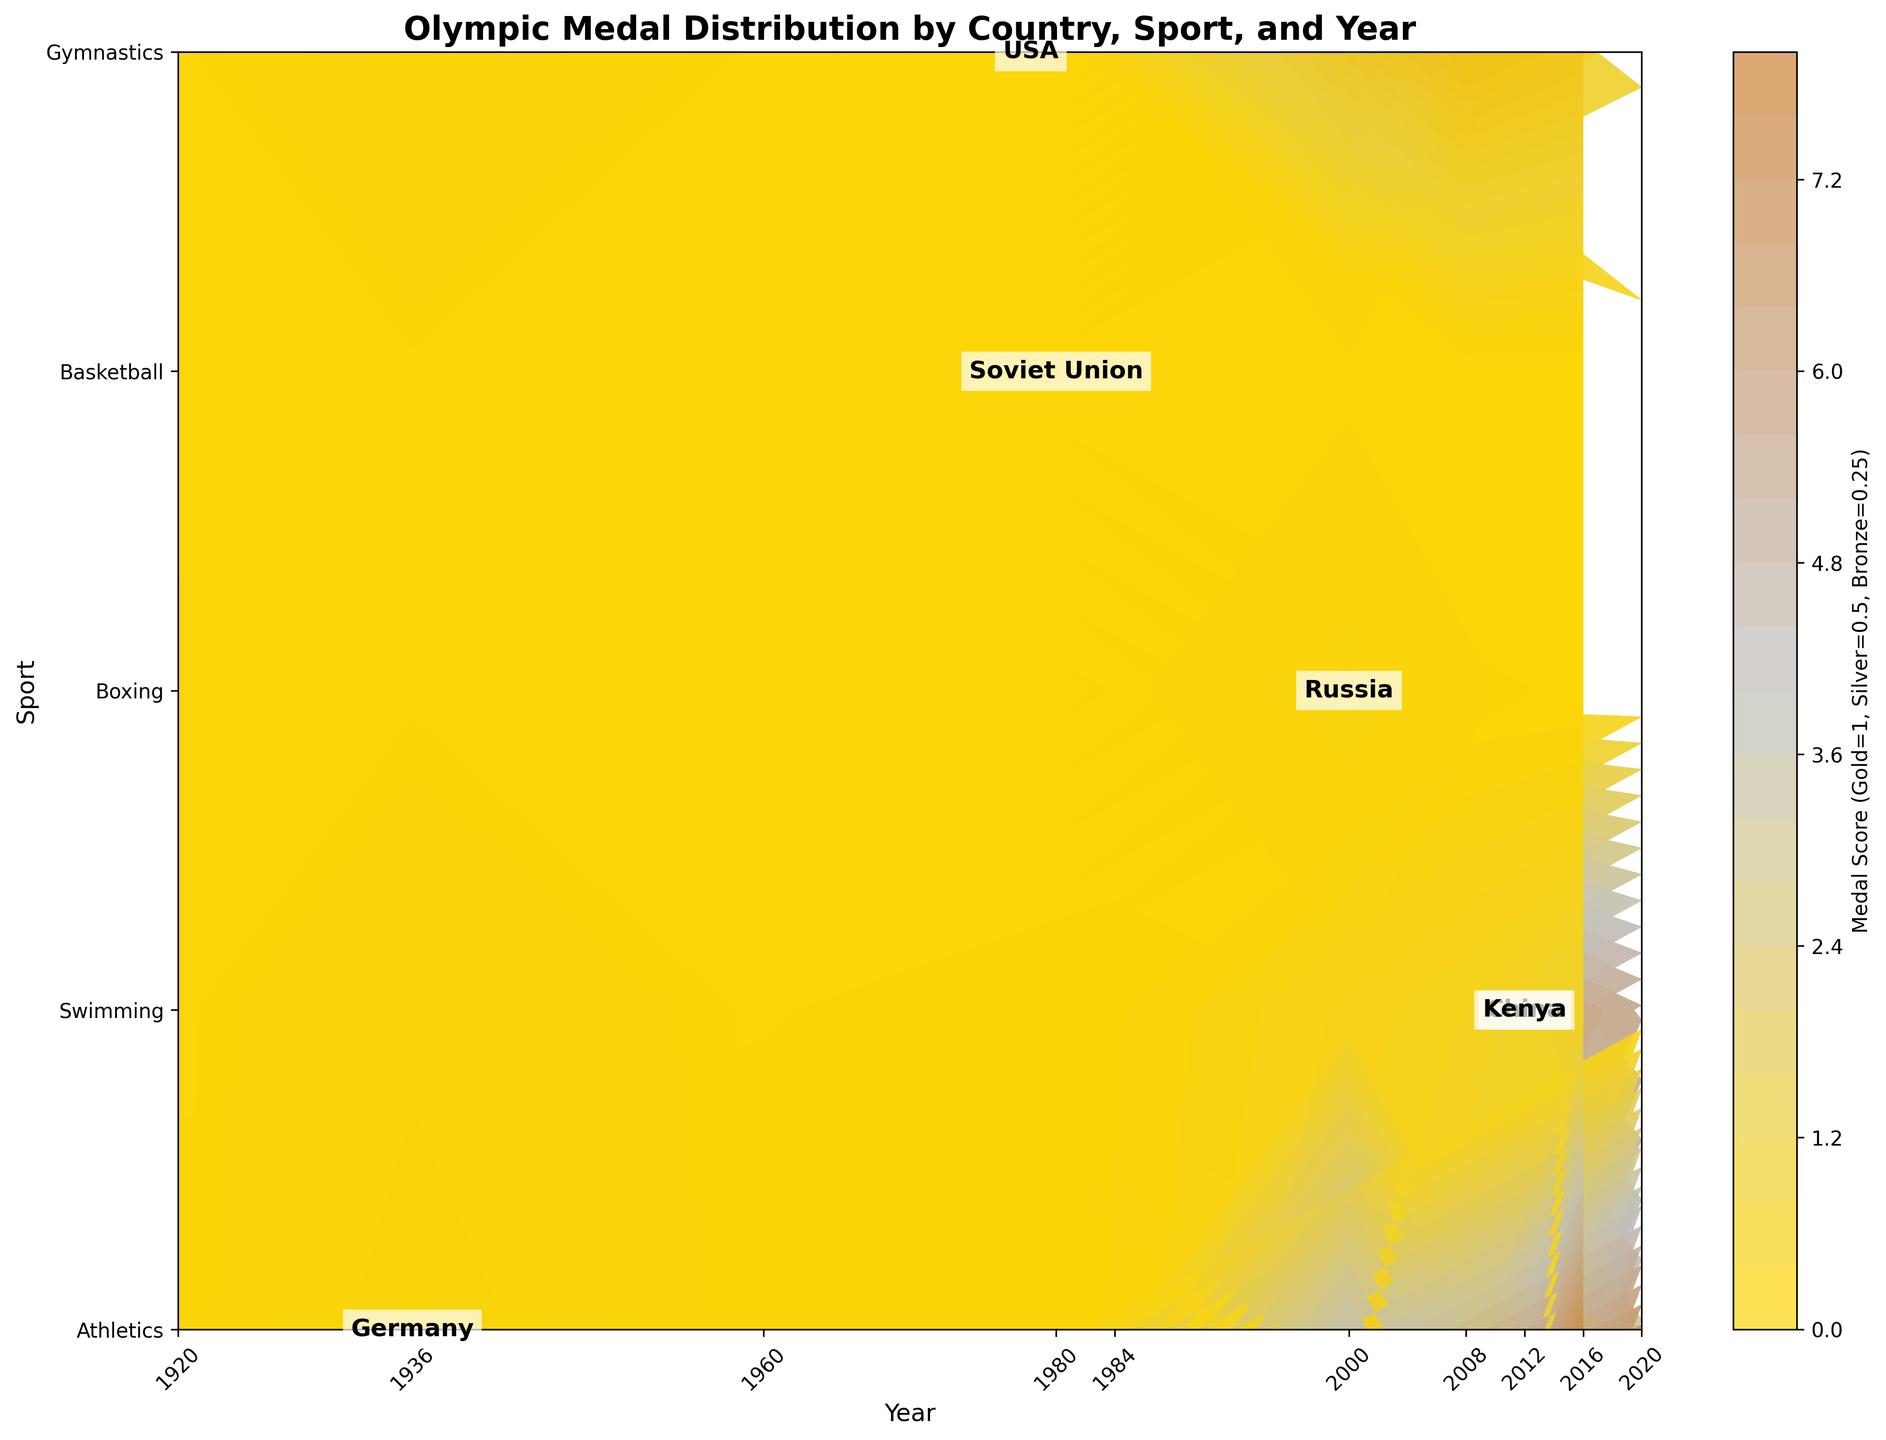What is the title of the figure? The title is usually located at the top of the figure and provides a summary of what the graph represents.
Answer: Olympic Medal Distribution by Country, Sport, and Year On which axis are the sports labeled? Typically, either the x-axis or y-axis is used to label different categories. In this case, the sports are labeled on the vertical axis.
Answer: y-axis Which sport does the USA win the most medals in the year 1984? To find this, locate the year 1984 on the x-axis, then look upwards to find the sport with the highest contour level for the USA.
Answer: Athletics How many countries are labeled in the figure? Count the number of unique country labels presented on the graph. The country labels are added as text on the plot.
Answer: 6 Does any country have a higher medal score in Swimming than USA in 2000? Compare the contour level for Swimming in the year 2000 among all countries. The USA's contour level for Swimming in 2000 must be compared to those of other countries for the same sport and year.
Answer: No Which country has the highest overall medal score in Gymnastics in 2012? Locate the year 2012 on the x-axis and find the contour levels corresponding to Gymnastics for all countries. The country with the highest contour level wins.
Answer: USA Which two sports show the highest medal scores for China in any year? Find the contour levels for China across all sports and all years, identifying the two sports with the highest contour levels.
Answer: Gymnastics and Athletics Compare the medal score trend for Kenya in Athletics over the years 2000 to 2020. Identify the years 2000, 2016, and 2020 on the x-axis and look at the respective contour levels for Kenya in the Athletics row. Check if the trend is increasing, decreasing, or constant.
Answer: Increasing Which country had a notable medal score increase in Boxing from 1920 to 1980? Locate the years 1920 and 1980 on the x-axis and find the contour levels for Boxing in those years for each country. Identify the country with a noticeable increase.
Answer: Soviet Union What was the medal score trend for the USA in Athletics from 1960 to 2020? Identify the years 1960, 2000, 2012, and 2020 on the x-axis, then look at the respective contour levels for the USA in the Athletics row. Determine if the score is increasing, decreasing, or remaining constant.
Answer: Decreasing 